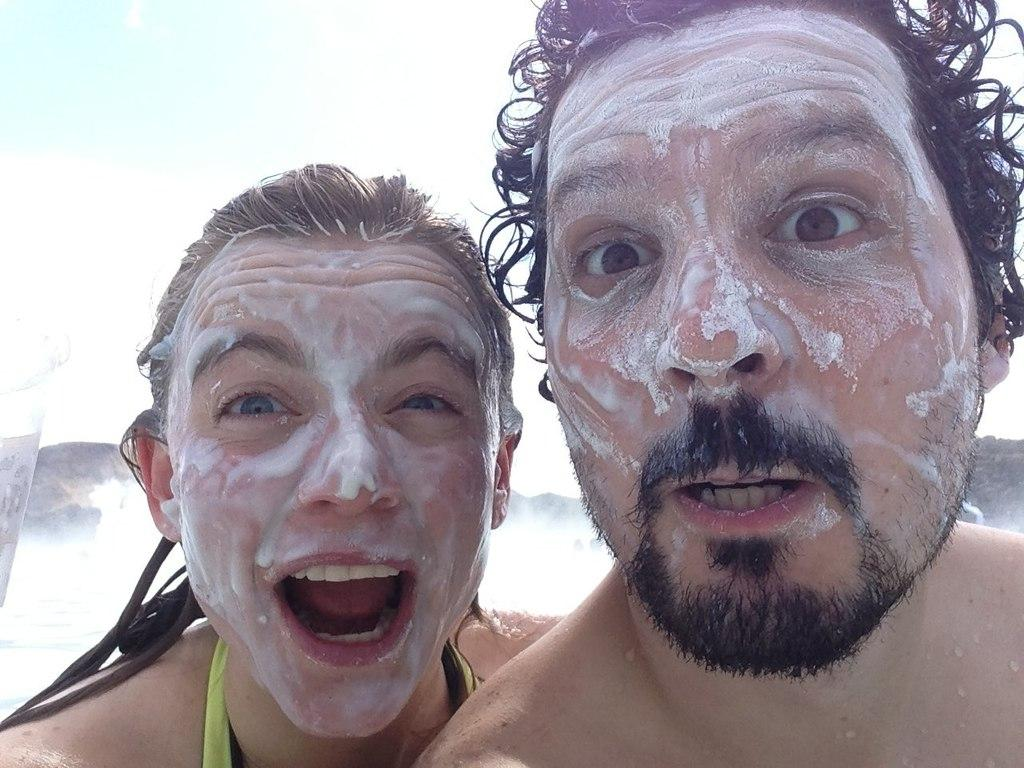How many people are in the image? There are two people in the image. What are the people doing in the image? The people have applied cream on their faces. What type of coal is being used by the people in the image? There is no coal present in the image; the people have applied cream on their faces. 